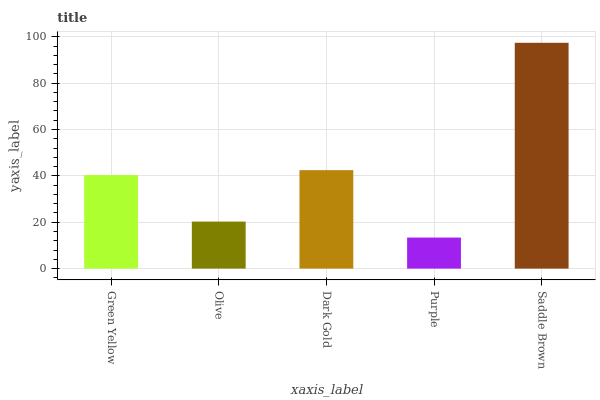Is Purple the minimum?
Answer yes or no. Yes. Is Saddle Brown the maximum?
Answer yes or no. Yes. Is Olive the minimum?
Answer yes or no. No. Is Olive the maximum?
Answer yes or no. No. Is Green Yellow greater than Olive?
Answer yes or no. Yes. Is Olive less than Green Yellow?
Answer yes or no. Yes. Is Olive greater than Green Yellow?
Answer yes or no. No. Is Green Yellow less than Olive?
Answer yes or no. No. Is Green Yellow the high median?
Answer yes or no. Yes. Is Green Yellow the low median?
Answer yes or no. Yes. Is Olive the high median?
Answer yes or no. No. Is Dark Gold the low median?
Answer yes or no. No. 